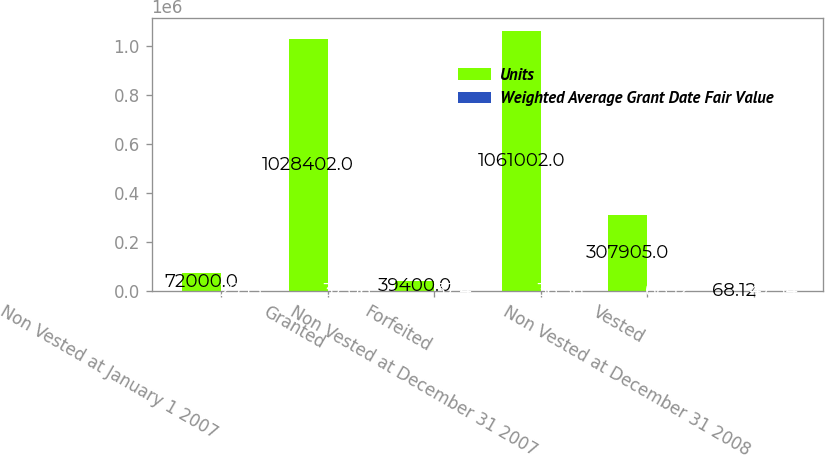Convert chart. <chart><loc_0><loc_0><loc_500><loc_500><stacked_bar_chart><ecel><fcel>Non Vested at January 1 2007<fcel>Granted<fcel>Forfeited<fcel>Non Vested at December 31 2007<fcel>Vested<fcel>Non Vested at December 31 2008<nl><fcel>Units<fcel>72000<fcel>1.0284e+06<fcel>39400<fcel>1.061e+06<fcel>307905<fcel>68.12<nl><fcel>Weighted Average Grant Date Fair Value<fcel>29.13<fcel>37.06<fcel>37.4<fcel>36.56<fcel>68.12<fcel>47.34<nl></chart> 